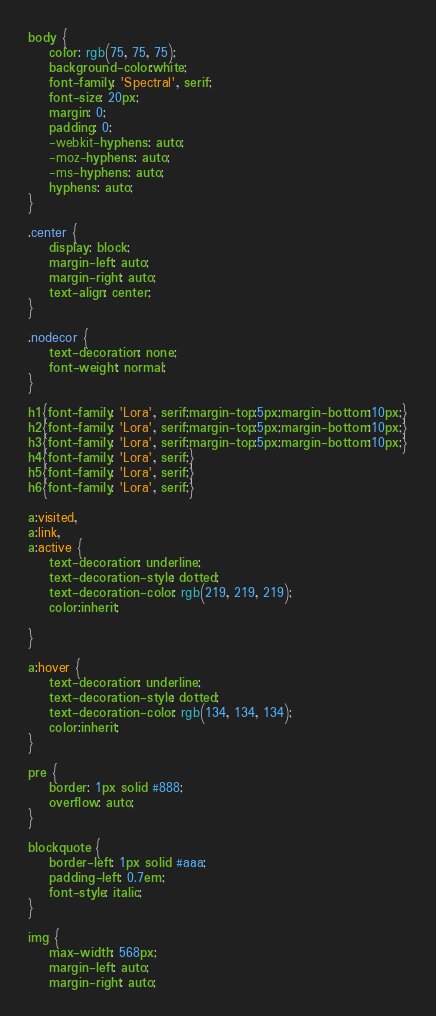<code> <loc_0><loc_0><loc_500><loc_500><_CSS_>body {
    color: rgb(75, 75, 75);
    background-color:white;
    font-family: 'Spectral', serif;
    font-size: 20px;
    margin: 0;
    padding: 0;
    -webkit-hyphens: auto;
    -moz-hyphens: auto;
    -ms-hyphens: auto;
    hyphens: auto;
}

.center {
    display: block;
    margin-left: auto;
    margin-right: auto;
    text-align: center;
}

.nodecor {
    text-decoration: none;
    font-weight: normal;
}

h1{font-family: 'Lora', serif;margin-top:5px;margin-bottom:10px;}
h2{font-family: 'Lora', serif;margin-top:5px;margin-bottom:10px;}
h3{font-family: 'Lora', serif;margin-top:5px;margin-bottom:10px;}
h4{font-family: 'Lora', serif;}
h5{font-family: 'Lora', serif;}
h6{font-family: 'Lora', serif;}

a:visited,
a:link,
a:active {
    text-decoration: underline;
    text-decoration-style: dotted;
    text-decoration-color: rgb(219, 219, 219);
    color:inherit; 
    
}

a:hover {
    text-decoration: underline;
    text-decoration-style: dotted;
    text-decoration-color: rgb(134, 134, 134);
    color:inherit; 
}

pre {
    border: 1px solid #888;
    overflow: auto;
}

blockquote {
    border-left: 1px solid #aaa;
    padding-left: 0.7em;
    font-style: italic;
}

img {
    max-width: 568px;
    margin-left: auto;
    margin-right: auto;</code> 